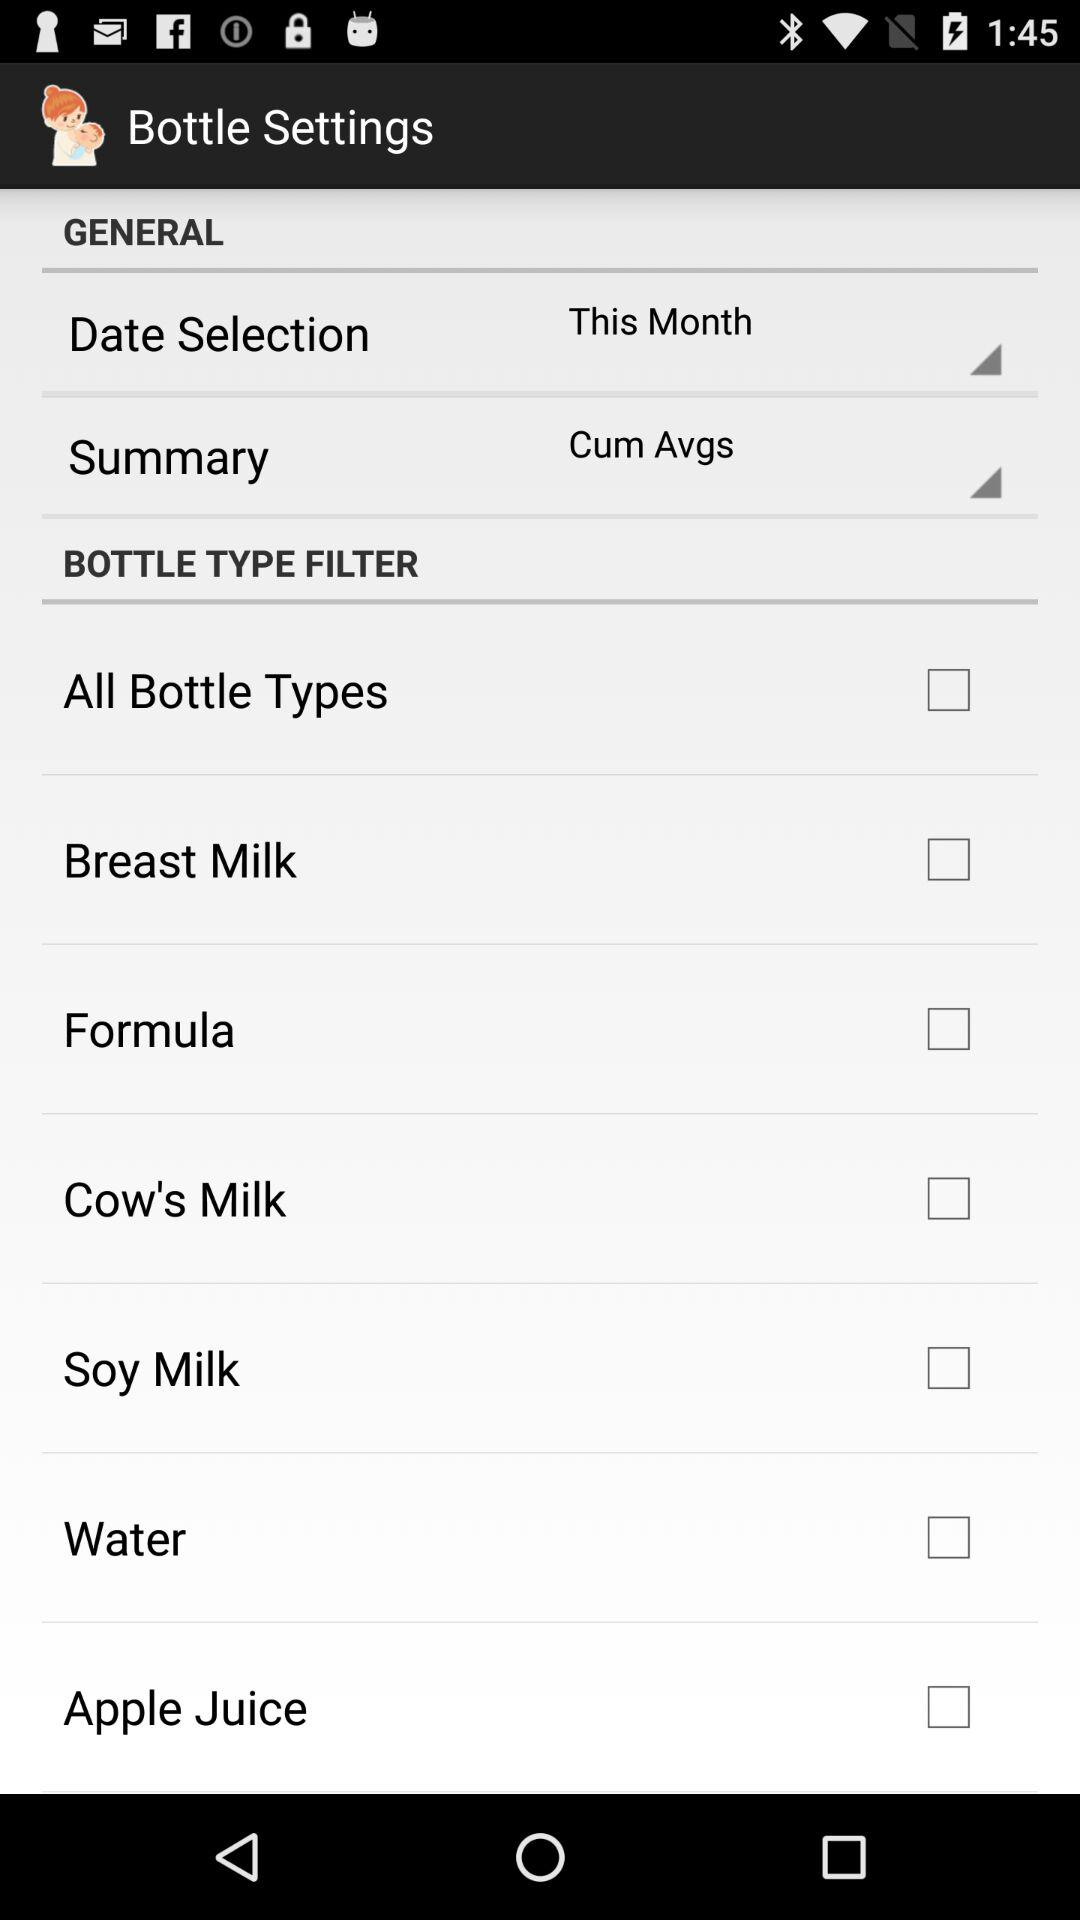What's the status of "Breast Milk"? The status of "Breast Milk" is "off". 